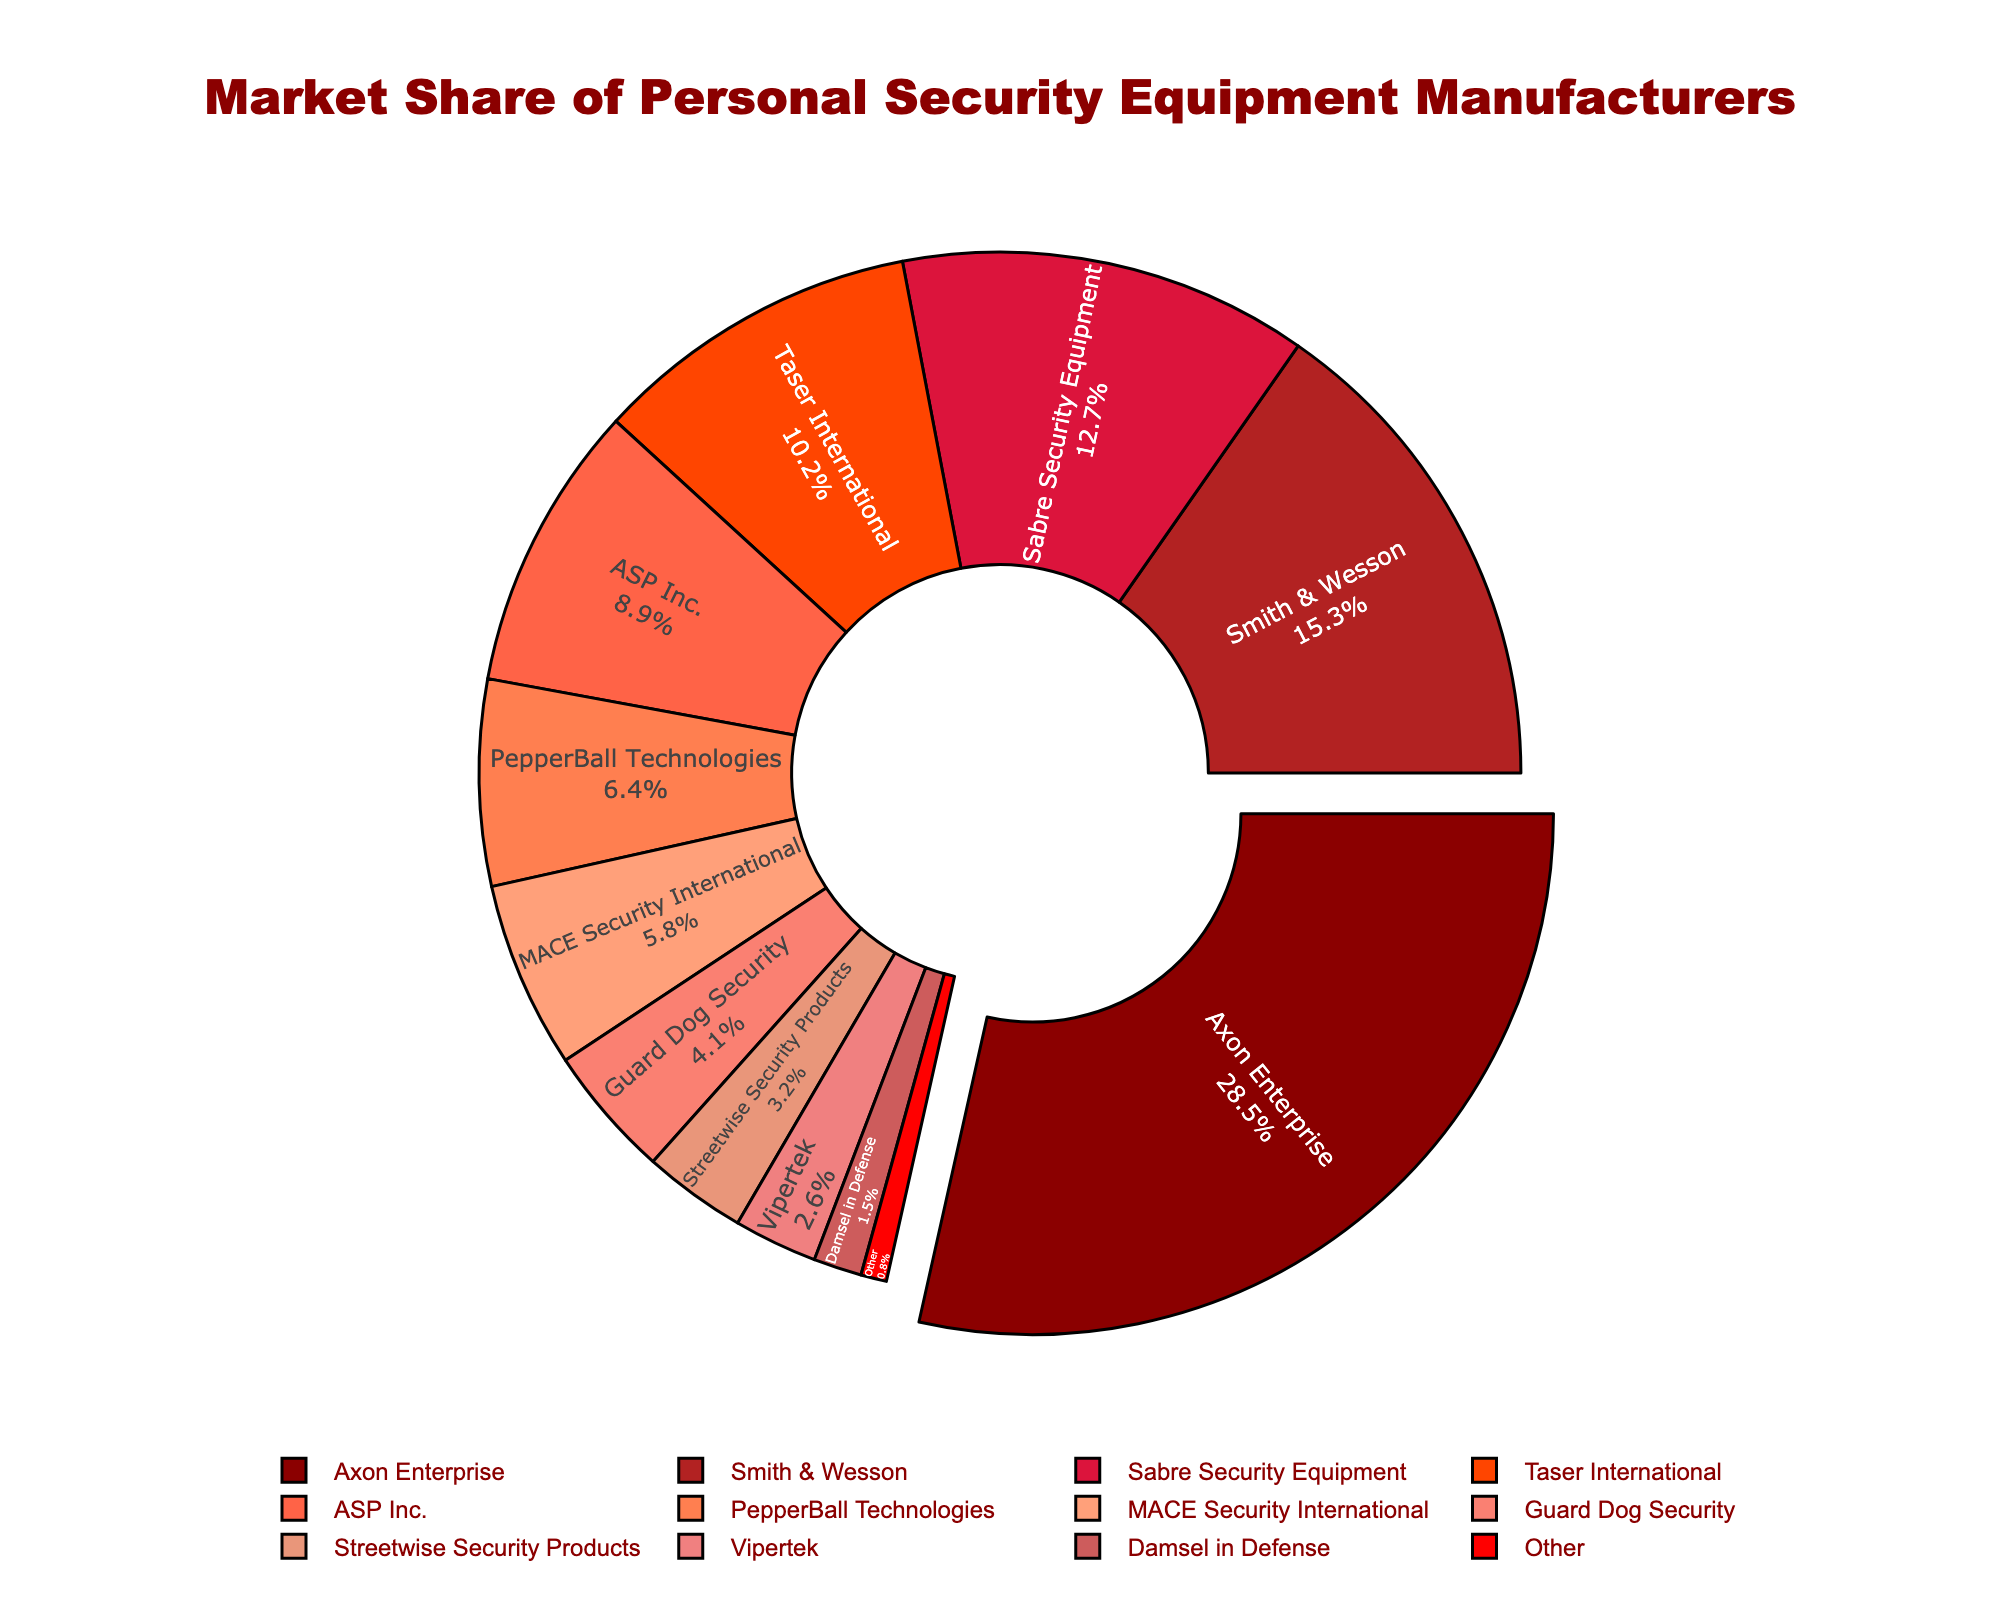Which manufacturer has the largest market share? The manufacturer with the largest market share is the one whose segment is slightly pulled out from the pie chart. This is Axon Enterprise with a market share of 28.5%.
Answer: Axon Enterprise Which two manufacturers together have a market share of less than 5%? By looking at the smallest segments of the pie chart, Guard Dog Security and Vipertek have market shares of 4.1% and 2.6% respectively, so their combined share is less than 5%.
Answer: Vipertek and Damsel in Defense How much more market share does Axon Enterprise have than ASP Inc.? Axon Enterprise has a market share of 28.5%, while ASP Inc. has 8.9%. The difference between their market shares is 28.5% - 8.9% = 19.6%.
Answer: 19.6% What is the combined market share of the top three manufacturers? The top three manufacturers by market share are Axon Enterprise (28.5%), Smith & Wesson (15.3%), and Sabre Security Equipment (12.7%). Their combined share is 28.5% + 15.3% + 12.7% = 56.5%.
Answer: 56.5% Which manufacturer's market share is just below Smith & Wesson's? The market share just below Smith & Wesson's 15.3% is Sabre Security Equipment with 12.7%.
Answer: Sabre Security Equipment What percentage of the market is covered by manufacturers with less than 5% share each? Manufacturers with less than 5% share each are Guard Dog Security (4.1%), Streetwise Security Products (3.2%), Vipertek (2.6%), Damsel in Defense (1.5%), and Other (0.8%). Their combined share is 4.1% + 3.2% + 2.6% + 1.5% + 0.8% = 12.2%.
Answer: 12.2% Is the market share of MACE Security International greater than or equal to PepperBall Technologies? MACE Security International has a market share of 5.8%, while PepperBall Technologies has 6.4%. Since 5.8% is less than 6.4%, MACE Security International does not have a greater market share.
Answer: No What is the total market share of Taser International and PepperBall Technologies combined? Taser International has a market share of 10.2% and PepperBall Technologies has a market share of 6.4%. Combined, their market share is 10.2% + 6.4% = 16.6%.
Answer: 16.6% Which manufacturer has the smallest market share and what is it? The manufacturer with the smallest market share is "Other" with a market share of 0.8%.
Answer: Other, 0.8% 